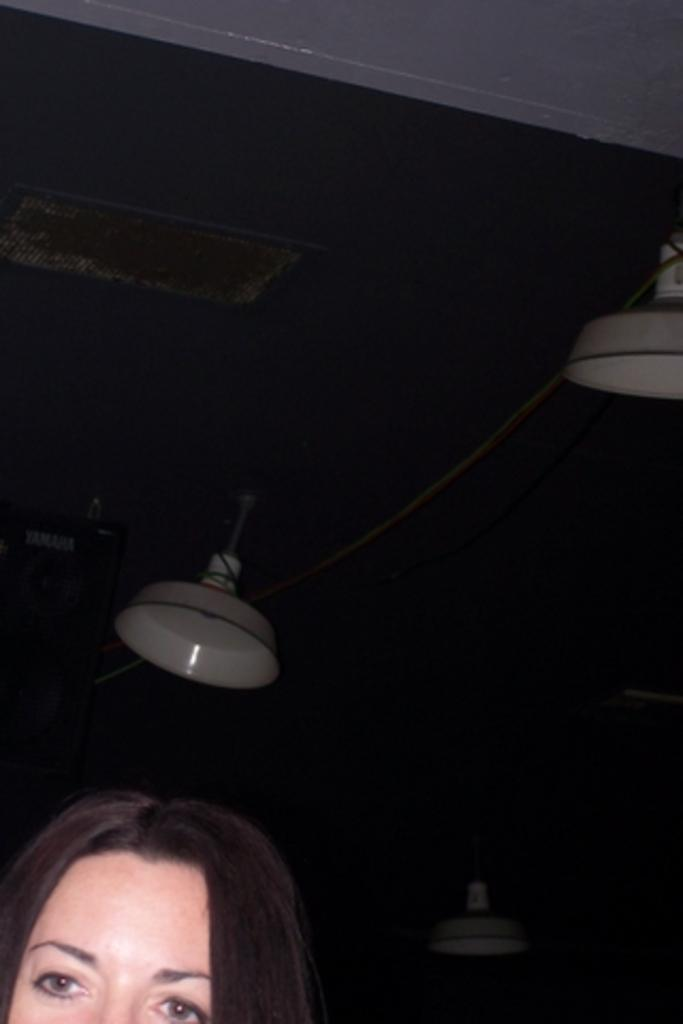Who is present at the bottom of the image? There is a woman at the bottom of the image. What can be seen at the top of the image? There is a ceiling with some objects at the top of the image. What type of flame can be seen on the horses in the image? There are no horses or flames present in the image. 